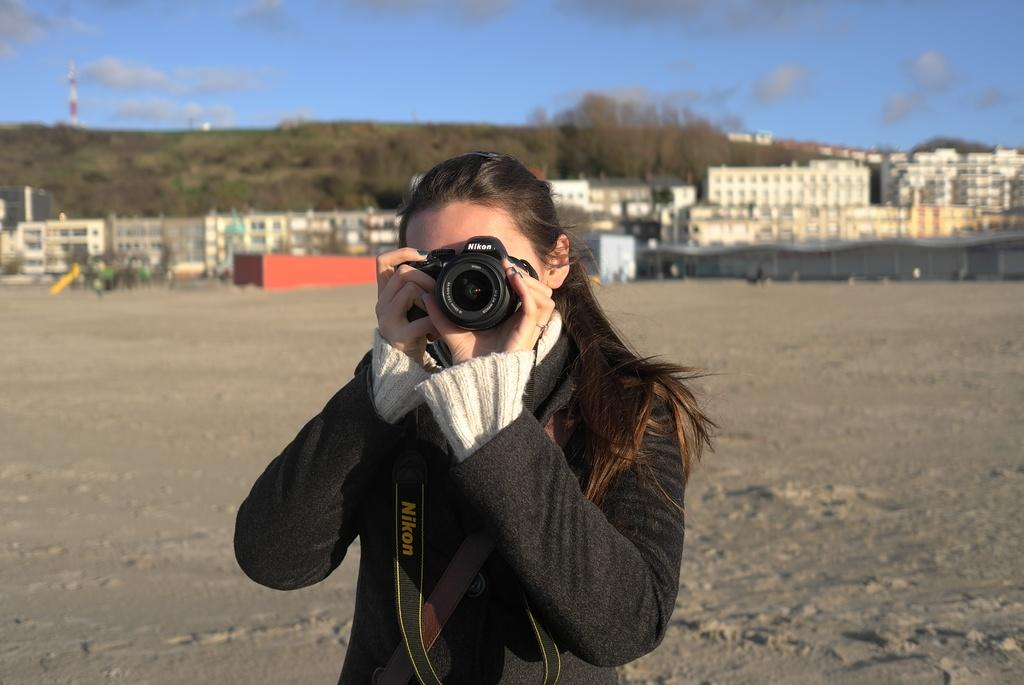Who is the main subject in the image? There is a woman in the image. What is the woman holding in the image? The woman is holding a camera. What can be seen in the background of the image? There are buildings visible in the background of the image. Is there a dock visible in the image? There is no dock present in the image. What type of grass can be seen growing near the woman in the image? There is no grass visible in the image; it features a woman holding a camera and buildings in the background. 